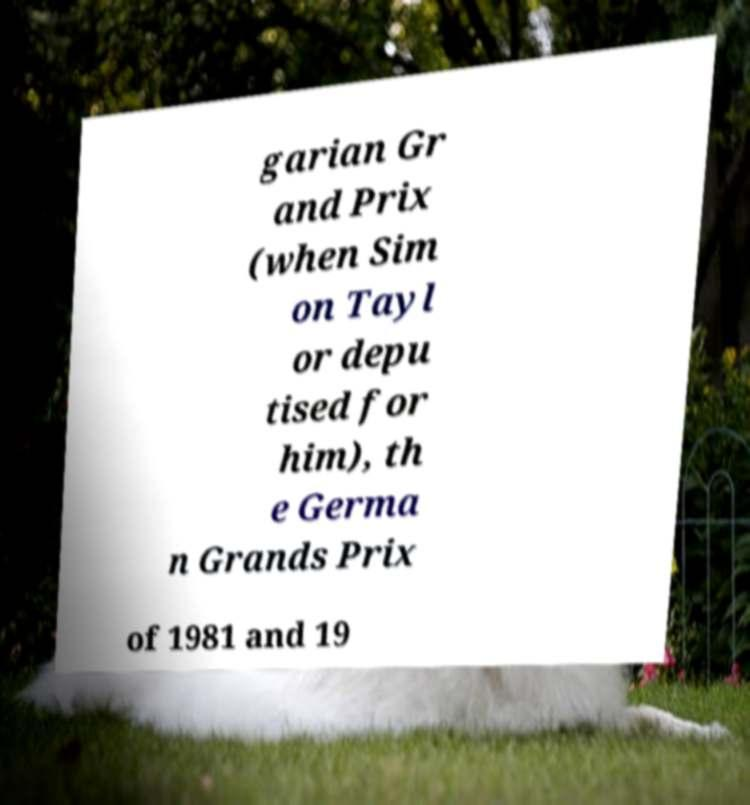Can you accurately transcribe the text from the provided image for me? garian Gr and Prix (when Sim on Tayl or depu tised for him), th e Germa n Grands Prix of 1981 and 19 